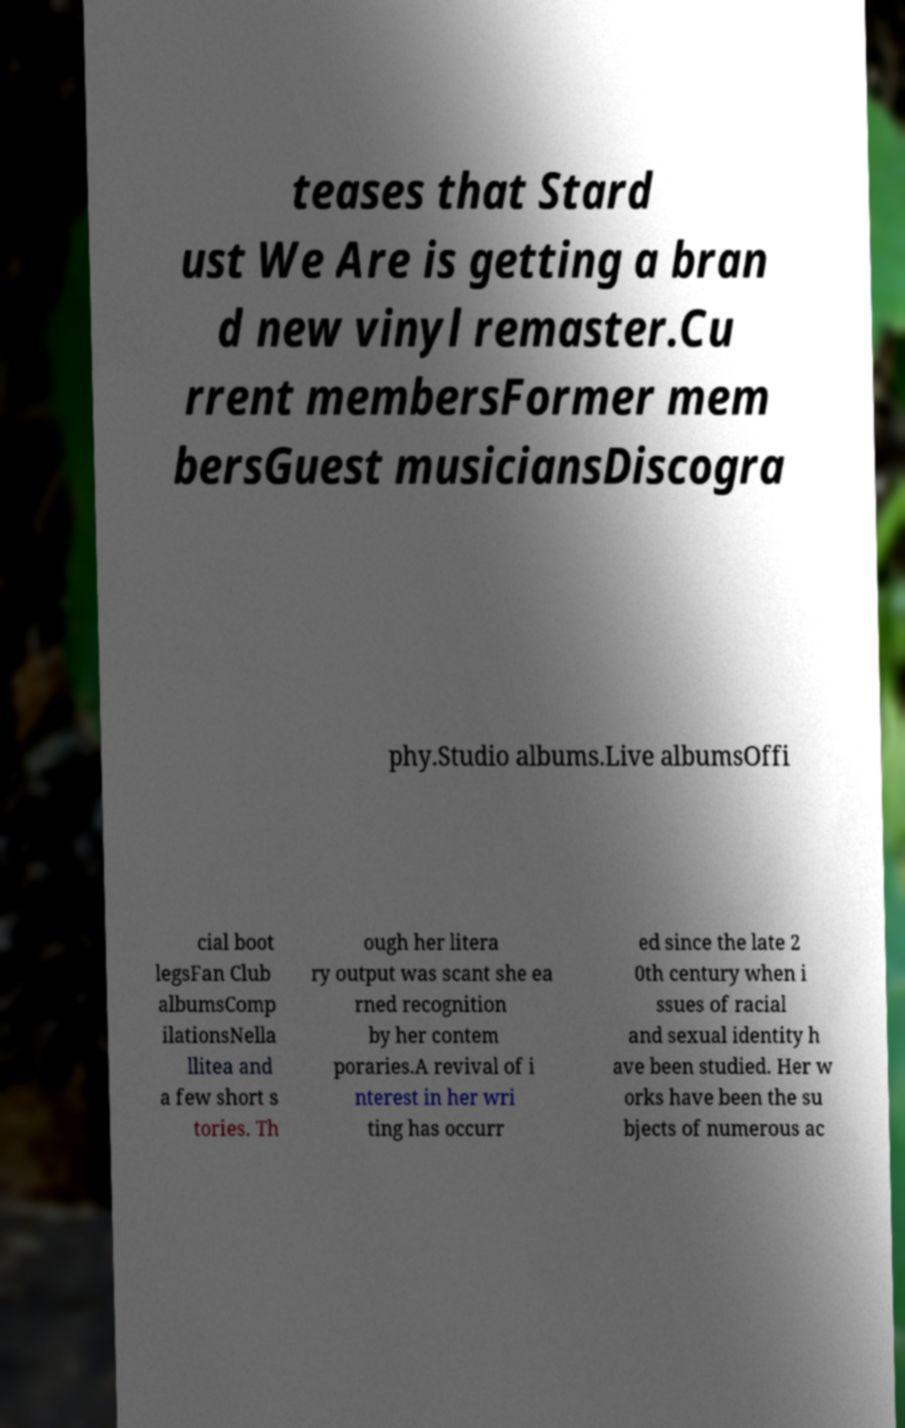What messages or text are displayed in this image? I need them in a readable, typed format. teases that Stard ust We Are is getting a bran d new vinyl remaster.Cu rrent membersFormer mem bersGuest musiciansDiscogra phy.Studio albums.Live albumsOffi cial boot legsFan Club albumsComp ilationsNella llitea and a few short s tories. Th ough her litera ry output was scant she ea rned recognition by her contem poraries.A revival of i nterest in her wri ting has occurr ed since the late 2 0th century when i ssues of racial and sexual identity h ave been studied. Her w orks have been the su bjects of numerous ac 